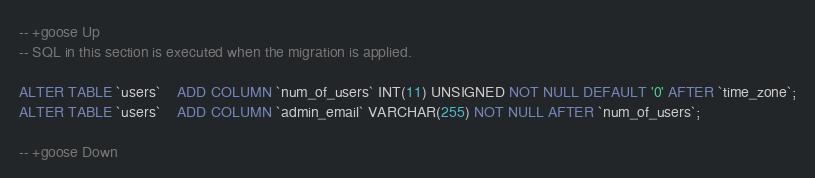<code> <loc_0><loc_0><loc_500><loc_500><_SQL_>-- +goose Up
-- SQL in this section is executed when the migration is applied.

ALTER TABLE `users`	ADD COLUMN `num_of_users` INT(11) UNSIGNED NOT NULL DEFAULT '0' AFTER `time_zone`;
ALTER TABLE `users`	ADD COLUMN `admin_email` VARCHAR(255) NOT NULL AFTER `num_of_users`;

-- +goose Down</code> 